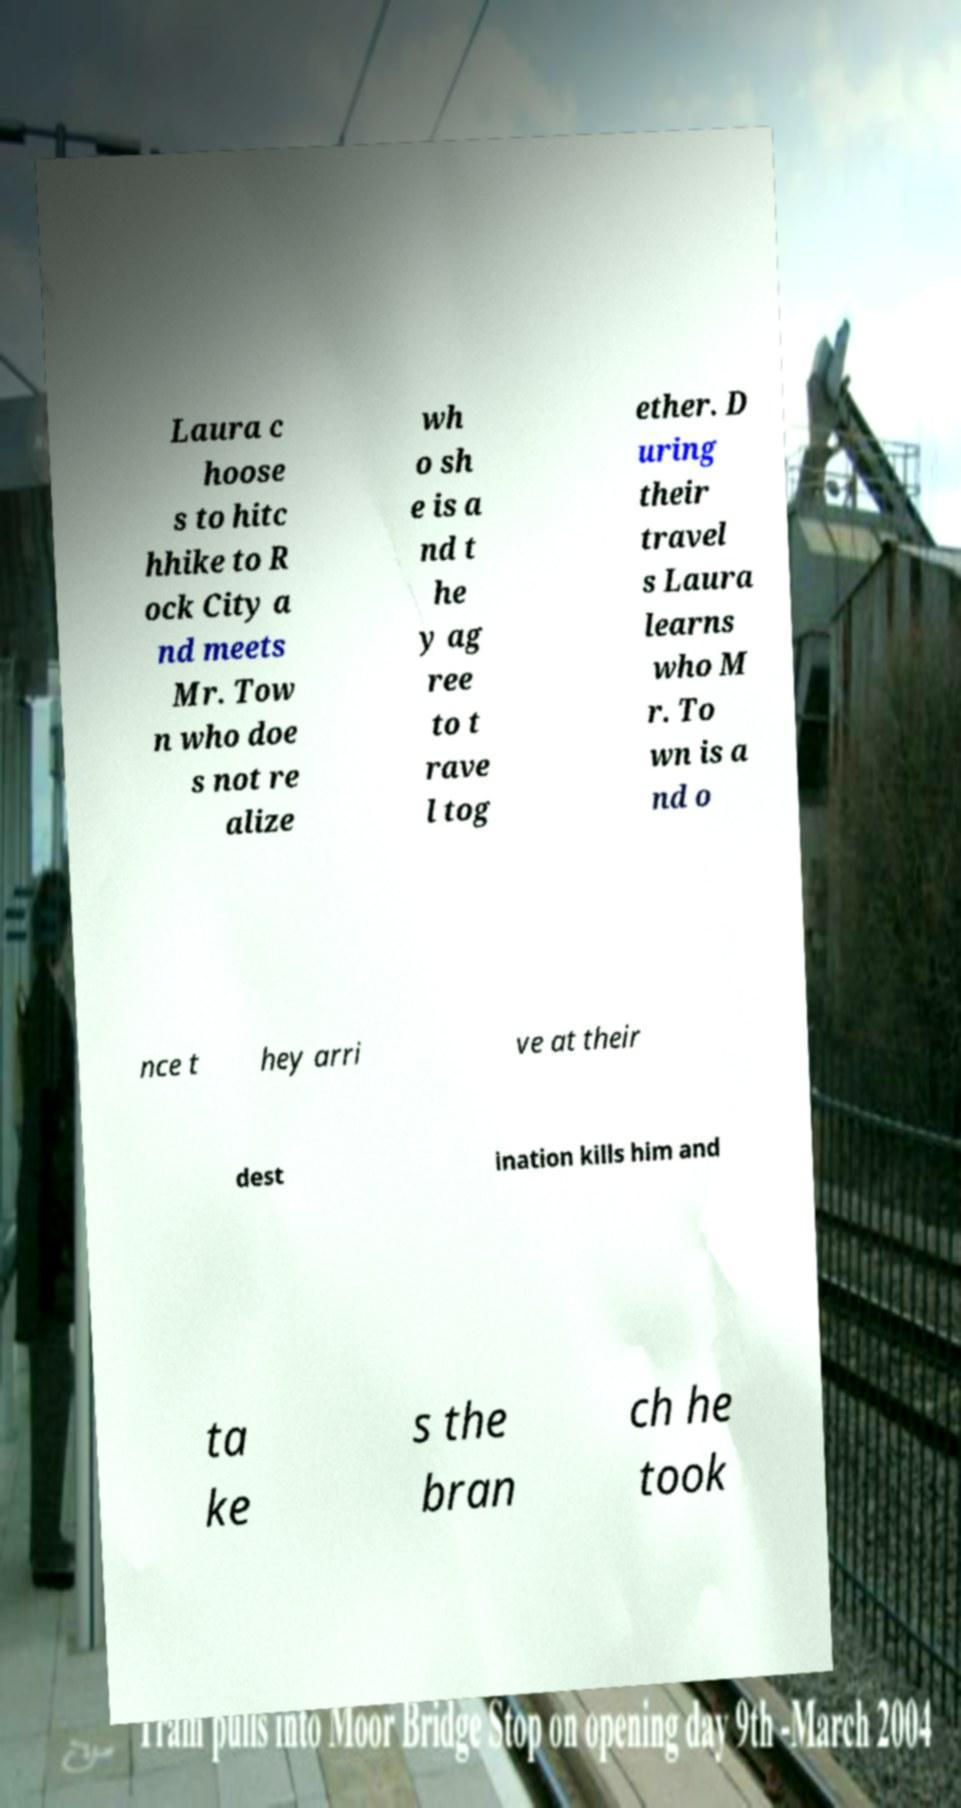I need the written content from this picture converted into text. Can you do that? Laura c hoose s to hitc hhike to R ock City a nd meets Mr. Tow n who doe s not re alize wh o sh e is a nd t he y ag ree to t rave l tog ether. D uring their travel s Laura learns who M r. To wn is a nd o nce t hey arri ve at their dest ination kills him and ta ke s the bran ch he took 